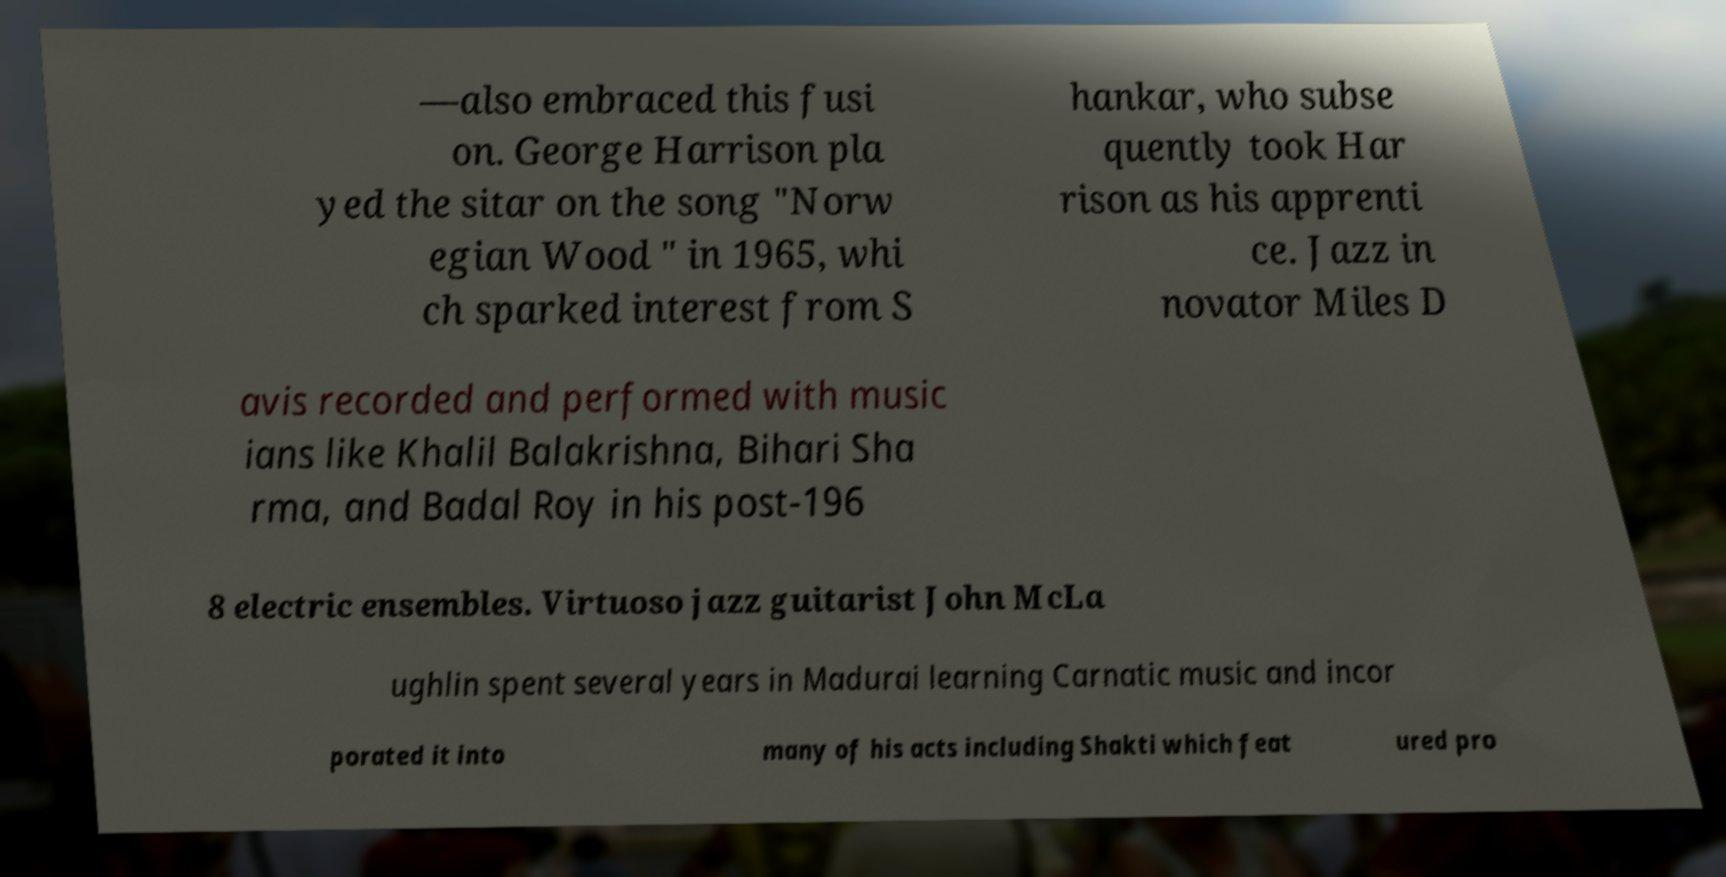Can you accurately transcribe the text from the provided image for me? —also embraced this fusi on. George Harrison pla yed the sitar on the song "Norw egian Wood " in 1965, whi ch sparked interest from S hankar, who subse quently took Har rison as his apprenti ce. Jazz in novator Miles D avis recorded and performed with music ians like Khalil Balakrishna, Bihari Sha rma, and Badal Roy in his post-196 8 electric ensembles. Virtuoso jazz guitarist John McLa ughlin spent several years in Madurai learning Carnatic music and incor porated it into many of his acts including Shakti which feat ured pro 